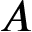<formula> <loc_0><loc_0><loc_500><loc_500>A</formula> 